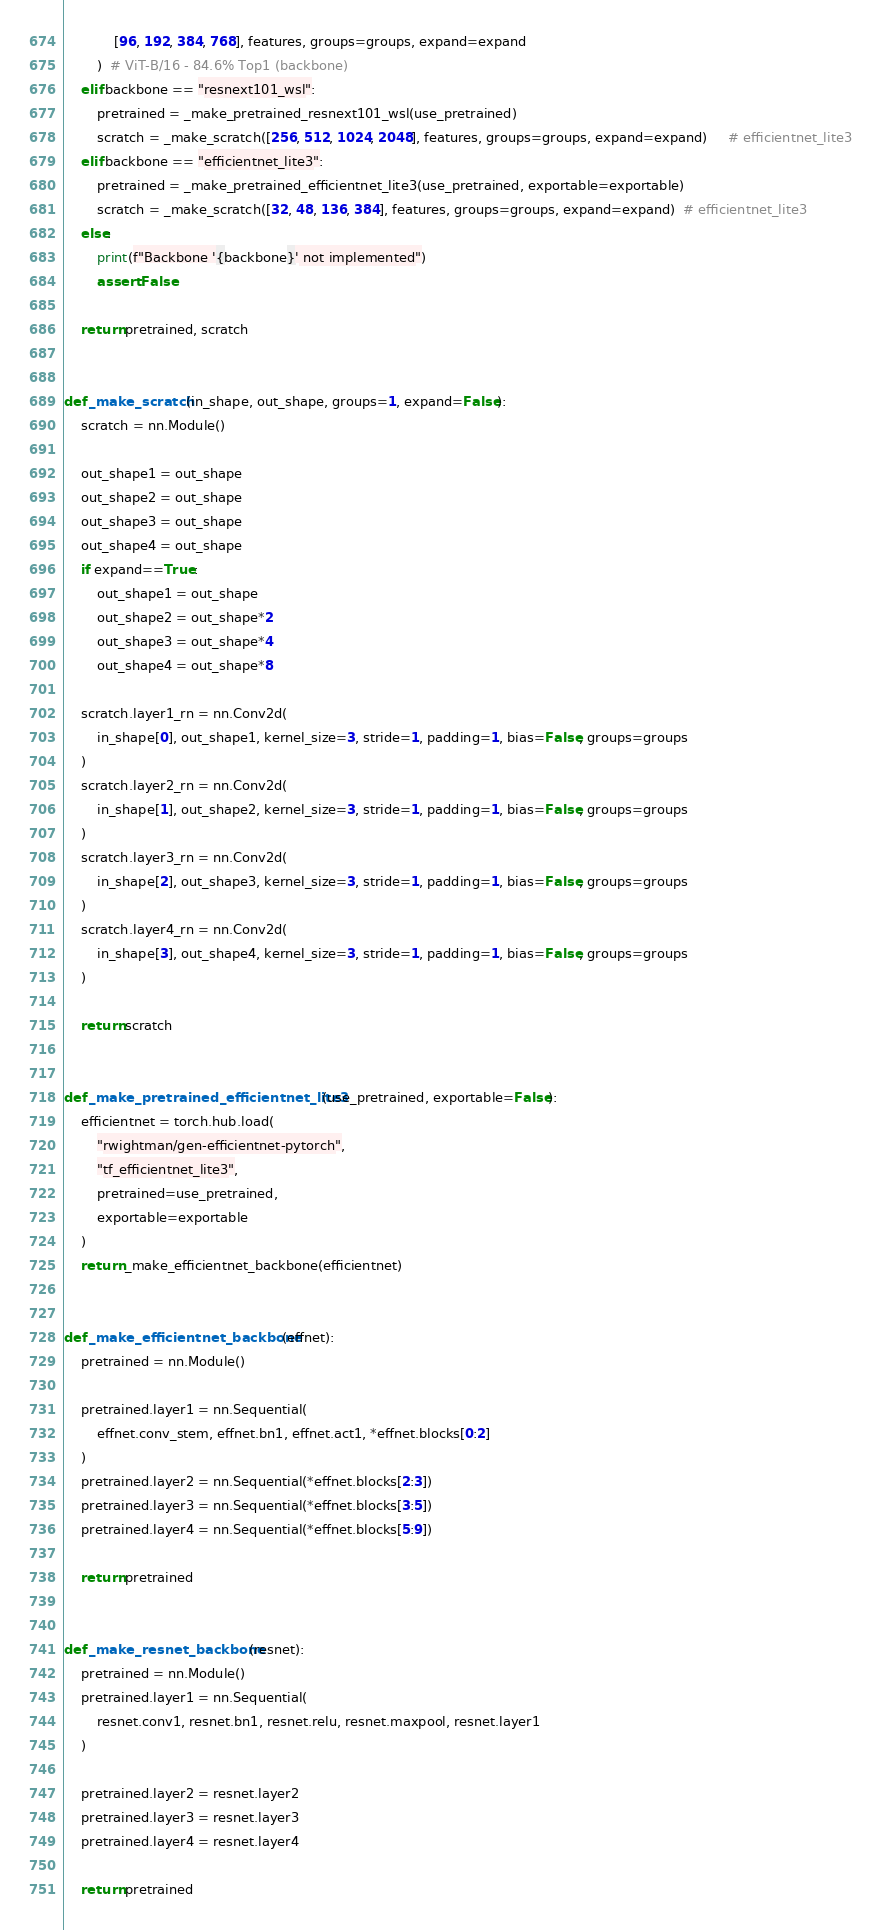Convert code to text. <code><loc_0><loc_0><loc_500><loc_500><_Python_>            [96, 192, 384, 768], features, groups=groups, expand=expand
        )  # ViT-B/16 - 84.6% Top1 (backbone)
    elif backbone == "resnext101_wsl":
        pretrained = _make_pretrained_resnext101_wsl(use_pretrained)
        scratch = _make_scratch([256, 512, 1024, 2048], features, groups=groups, expand=expand)     # efficientnet_lite3  
    elif backbone == "efficientnet_lite3":
        pretrained = _make_pretrained_efficientnet_lite3(use_pretrained, exportable=exportable)
        scratch = _make_scratch([32, 48, 136, 384], features, groups=groups, expand=expand)  # efficientnet_lite3     
    else:
        print(f"Backbone '{backbone}' not implemented")
        assert False

    return pretrained, scratch


def _make_scratch(in_shape, out_shape, groups=1, expand=False):
    scratch = nn.Module()

    out_shape1 = out_shape
    out_shape2 = out_shape
    out_shape3 = out_shape
    out_shape4 = out_shape
    if expand==True:
        out_shape1 = out_shape
        out_shape2 = out_shape*2
        out_shape3 = out_shape*4
        out_shape4 = out_shape*8

    scratch.layer1_rn = nn.Conv2d(
        in_shape[0], out_shape1, kernel_size=3, stride=1, padding=1, bias=False, groups=groups
    )
    scratch.layer2_rn = nn.Conv2d(
        in_shape[1], out_shape2, kernel_size=3, stride=1, padding=1, bias=False, groups=groups
    )
    scratch.layer3_rn = nn.Conv2d(
        in_shape[2], out_shape3, kernel_size=3, stride=1, padding=1, bias=False, groups=groups
    )
    scratch.layer4_rn = nn.Conv2d(
        in_shape[3], out_shape4, kernel_size=3, stride=1, padding=1, bias=False, groups=groups
    )

    return scratch


def _make_pretrained_efficientnet_lite3(use_pretrained, exportable=False):
    efficientnet = torch.hub.load(
        "rwightman/gen-efficientnet-pytorch",
        "tf_efficientnet_lite3",
        pretrained=use_pretrained,
        exportable=exportable
    )
    return _make_efficientnet_backbone(efficientnet)


def _make_efficientnet_backbone(effnet):
    pretrained = nn.Module()

    pretrained.layer1 = nn.Sequential(
        effnet.conv_stem, effnet.bn1, effnet.act1, *effnet.blocks[0:2]
    )
    pretrained.layer2 = nn.Sequential(*effnet.blocks[2:3])
    pretrained.layer3 = nn.Sequential(*effnet.blocks[3:5])
    pretrained.layer4 = nn.Sequential(*effnet.blocks[5:9])

    return pretrained
    

def _make_resnet_backbone(resnet):
    pretrained = nn.Module()
    pretrained.layer1 = nn.Sequential(
        resnet.conv1, resnet.bn1, resnet.relu, resnet.maxpool, resnet.layer1
    )

    pretrained.layer2 = resnet.layer2
    pretrained.layer3 = resnet.layer3
    pretrained.layer4 = resnet.layer4

    return pretrained

</code> 